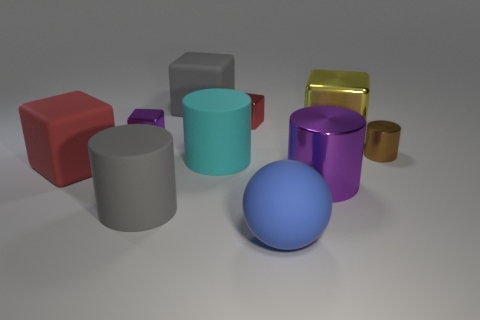What is the color of the shiny cylinder that is the same size as the matte ball?
Ensure brevity in your answer.  Purple. What number of things are either big gray objects that are behind the small red thing or red objects that are behind the cyan rubber cylinder?
Your response must be concise. 2. Is the number of big gray rubber cubes that are to the right of the red metallic block the same as the number of large blue things?
Give a very brief answer. No. Does the shiny block right of the matte sphere have the same size as the shiny cylinder behind the big purple cylinder?
Make the answer very short. No. What number of other objects are the same size as the cyan rubber thing?
Keep it short and to the point. 6. There is a red matte block behind the purple object in front of the purple block; is there a tiny brown shiny cylinder that is in front of it?
Ensure brevity in your answer.  No. Is there any other thing that is the same color as the small metal cylinder?
Keep it short and to the point. No. What size is the matte cylinder that is behind the big purple cylinder?
Offer a very short reply. Large. There is a matte cube to the right of the metal object that is to the left of the rubber cylinder that is behind the gray cylinder; how big is it?
Provide a succinct answer. Large. There is a matte cube to the right of the tiny thing left of the gray matte block; what is its color?
Your answer should be very brief. Gray. 